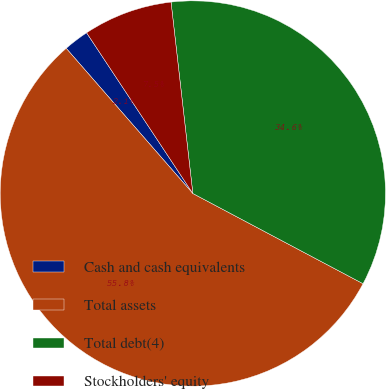Convert chart to OTSL. <chart><loc_0><loc_0><loc_500><loc_500><pie_chart><fcel>Cash and cash equivalents<fcel>Total assets<fcel>Total debt(4)<fcel>Stockholders' equity<nl><fcel>2.12%<fcel>55.82%<fcel>34.56%<fcel>7.49%<nl></chart> 